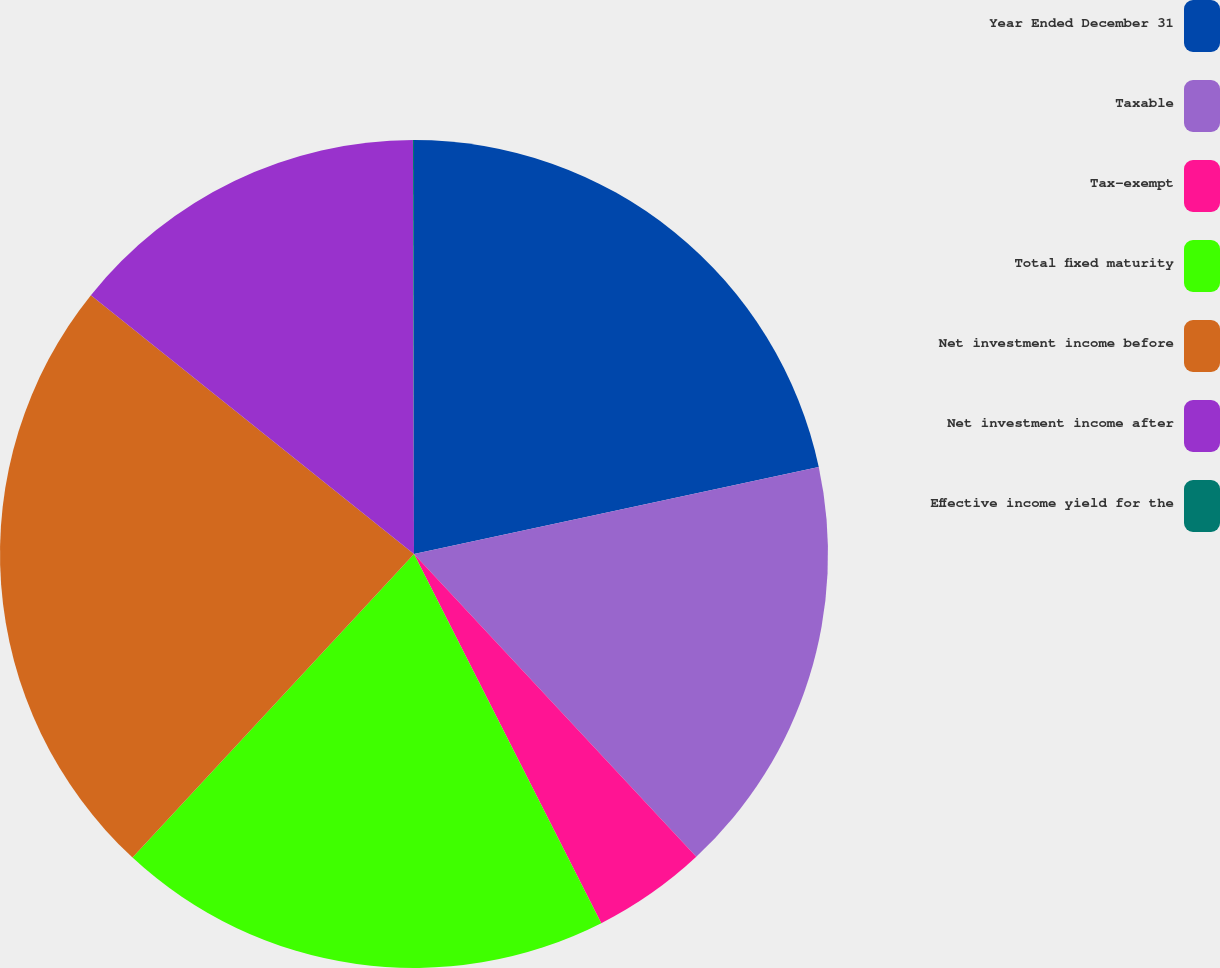<chart> <loc_0><loc_0><loc_500><loc_500><pie_chart><fcel>Year Ended December 31<fcel>Taxable<fcel>Tax-exempt<fcel>Total fixed maturity<fcel>Net investment income before<fcel>Net investment income after<fcel>Effective income yield for the<nl><fcel>21.63%<fcel>16.43%<fcel>4.47%<fcel>19.37%<fcel>23.85%<fcel>14.21%<fcel>0.04%<nl></chart> 